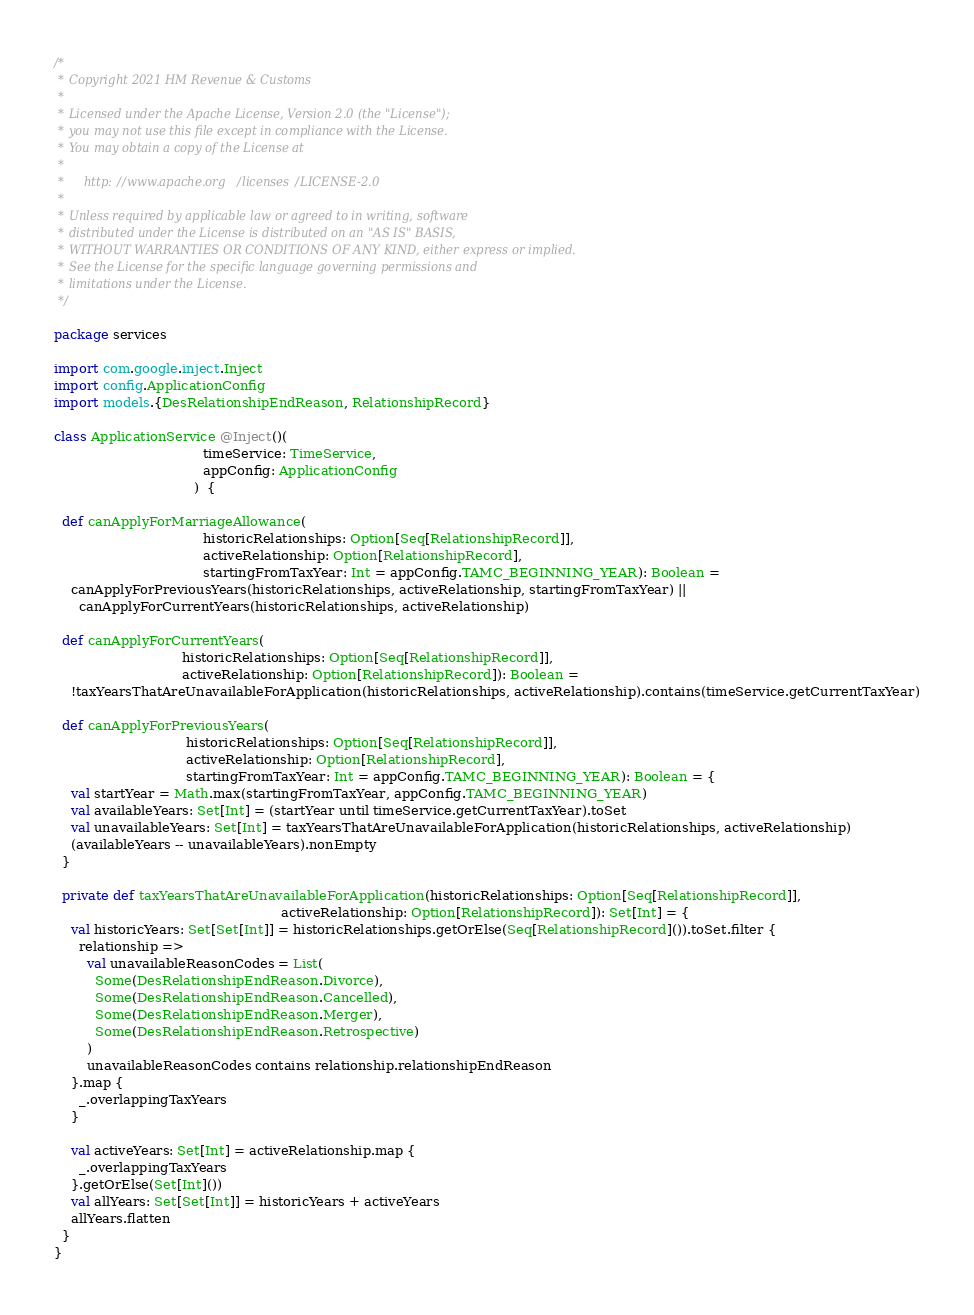Convert code to text. <code><loc_0><loc_0><loc_500><loc_500><_Scala_>/*
 * Copyright 2021 HM Revenue & Customs
 *
 * Licensed under the Apache License, Version 2.0 (the "License");
 * you may not use this file except in compliance with the License.
 * You may obtain a copy of the License at
 *
 *     http://www.apache.org/licenses/LICENSE-2.0
 *
 * Unless required by applicable law or agreed to in writing, software
 * distributed under the License is distributed on an "AS IS" BASIS,
 * WITHOUT WARRANTIES OR CONDITIONS OF ANY KIND, either express or implied.
 * See the License for the specific language governing permissions and
 * limitations under the License.
 */

package services

import com.google.inject.Inject
import config.ApplicationConfig
import models.{DesRelationshipEndReason, RelationshipRecord}

class ApplicationService @Inject()(
                                    timeService: TimeService,
                                    appConfig: ApplicationConfig
                                  )  {

  def canApplyForMarriageAllowance(
                                    historicRelationships: Option[Seq[RelationshipRecord]],
                                    activeRelationship: Option[RelationshipRecord],
                                    startingFromTaxYear: Int = appConfig.TAMC_BEGINNING_YEAR): Boolean =
    canApplyForPreviousYears(historicRelationships, activeRelationship, startingFromTaxYear) ||
      canApplyForCurrentYears(historicRelationships, activeRelationship)

  def canApplyForCurrentYears(
                               historicRelationships: Option[Seq[RelationshipRecord]],
                               activeRelationship: Option[RelationshipRecord]): Boolean =
    !taxYearsThatAreUnavailableForApplication(historicRelationships, activeRelationship).contains(timeService.getCurrentTaxYear)

  def canApplyForPreviousYears(
                                historicRelationships: Option[Seq[RelationshipRecord]],
                                activeRelationship: Option[RelationshipRecord],
                                startingFromTaxYear: Int = appConfig.TAMC_BEGINNING_YEAR): Boolean = {
    val startYear = Math.max(startingFromTaxYear, appConfig.TAMC_BEGINNING_YEAR)
    val availableYears: Set[Int] = (startYear until timeService.getCurrentTaxYear).toSet
    val unavailableYears: Set[Int] = taxYearsThatAreUnavailableForApplication(historicRelationships, activeRelationship)
    (availableYears -- unavailableYears).nonEmpty
  }

  private def taxYearsThatAreUnavailableForApplication(historicRelationships: Option[Seq[RelationshipRecord]],
                                                       activeRelationship: Option[RelationshipRecord]): Set[Int] = {
    val historicYears: Set[Set[Int]] = historicRelationships.getOrElse(Seq[RelationshipRecord]()).toSet.filter {
      relationship =>
        val unavailableReasonCodes = List(
          Some(DesRelationshipEndReason.Divorce),
          Some(DesRelationshipEndReason.Cancelled),
          Some(DesRelationshipEndReason.Merger),
          Some(DesRelationshipEndReason.Retrospective)
        )
        unavailableReasonCodes contains relationship.relationshipEndReason
    }.map {
      _.overlappingTaxYears
    }

    val activeYears: Set[Int] = activeRelationship.map {
      _.overlappingTaxYears
    }.getOrElse(Set[Int]())
    val allYears: Set[Set[Int]] = historicYears + activeYears
    allYears.flatten
  }
}
</code> 